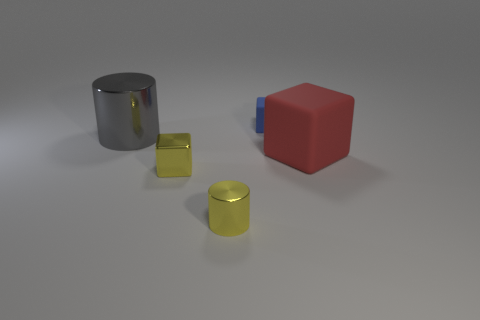What is the color of the object that is behind the small shiny block and in front of the big gray cylinder?
Your answer should be very brief. Red. Is the material of the large thing right of the tiny rubber block the same as the gray cylinder?
Offer a very short reply. No. There is a small metal block; is it the same color as the metal cylinder that is in front of the big cylinder?
Your answer should be compact. Yes. There is a big matte cube; are there any small yellow cubes on the left side of it?
Your response must be concise. Yes. There is a rubber thing that is in front of the blue matte object; does it have the same size as the gray metal cylinder in front of the small matte thing?
Offer a very short reply. Yes. Are there any cylinders that have the same size as the blue rubber block?
Your answer should be very brief. Yes. There is a big matte thing that is in front of the large shiny cylinder; is its shape the same as the small rubber object?
Give a very brief answer. Yes. What is the block right of the tiny matte block made of?
Offer a very short reply. Rubber. What is the shape of the yellow shiny object on the left side of the metal object on the right side of the small metallic block?
Offer a terse response. Cube. Do the big gray shiny object and the tiny yellow metallic object that is in front of the yellow block have the same shape?
Offer a terse response. Yes. 